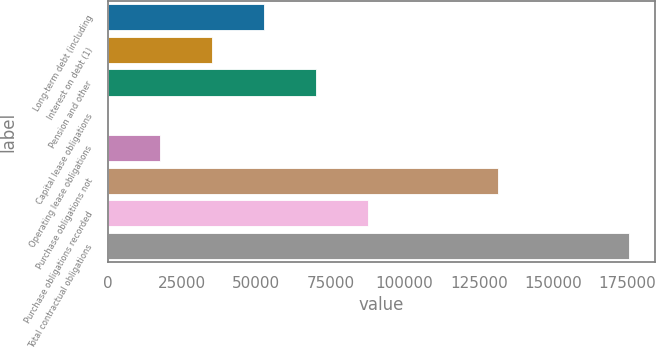Convert chart to OTSL. <chart><loc_0><loc_0><loc_500><loc_500><bar_chart><fcel>Long-term debt (including<fcel>Interest on debt (1)<fcel>Pension and other<fcel>Capital lease obligations<fcel>Operating lease obligations<fcel>Purchase obligations not<fcel>Purchase obligations recorded<fcel>Total contractual obligations<nl><fcel>52736.8<fcel>35214.2<fcel>70259.4<fcel>169<fcel>17691.6<fcel>131549<fcel>87782<fcel>175395<nl></chart> 